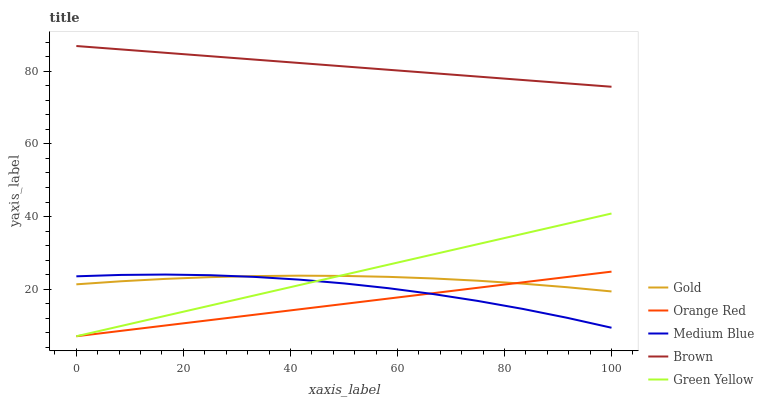Does Orange Red have the minimum area under the curve?
Answer yes or no. Yes. Does Brown have the maximum area under the curve?
Answer yes or no. Yes. Does Green Yellow have the minimum area under the curve?
Answer yes or no. No. Does Green Yellow have the maximum area under the curve?
Answer yes or no. No. Is Orange Red the smoothest?
Answer yes or no. Yes. Is Medium Blue the roughest?
Answer yes or no. Yes. Is Green Yellow the smoothest?
Answer yes or no. No. Is Green Yellow the roughest?
Answer yes or no. No. Does Medium Blue have the lowest value?
Answer yes or no. No. Does Brown have the highest value?
Answer yes or no. Yes. Does Green Yellow have the highest value?
Answer yes or no. No. Is Green Yellow less than Brown?
Answer yes or no. Yes. Is Brown greater than Orange Red?
Answer yes or no. Yes. Does Green Yellow intersect Gold?
Answer yes or no. Yes. Is Green Yellow less than Gold?
Answer yes or no. No. Is Green Yellow greater than Gold?
Answer yes or no. No. Does Green Yellow intersect Brown?
Answer yes or no. No. 